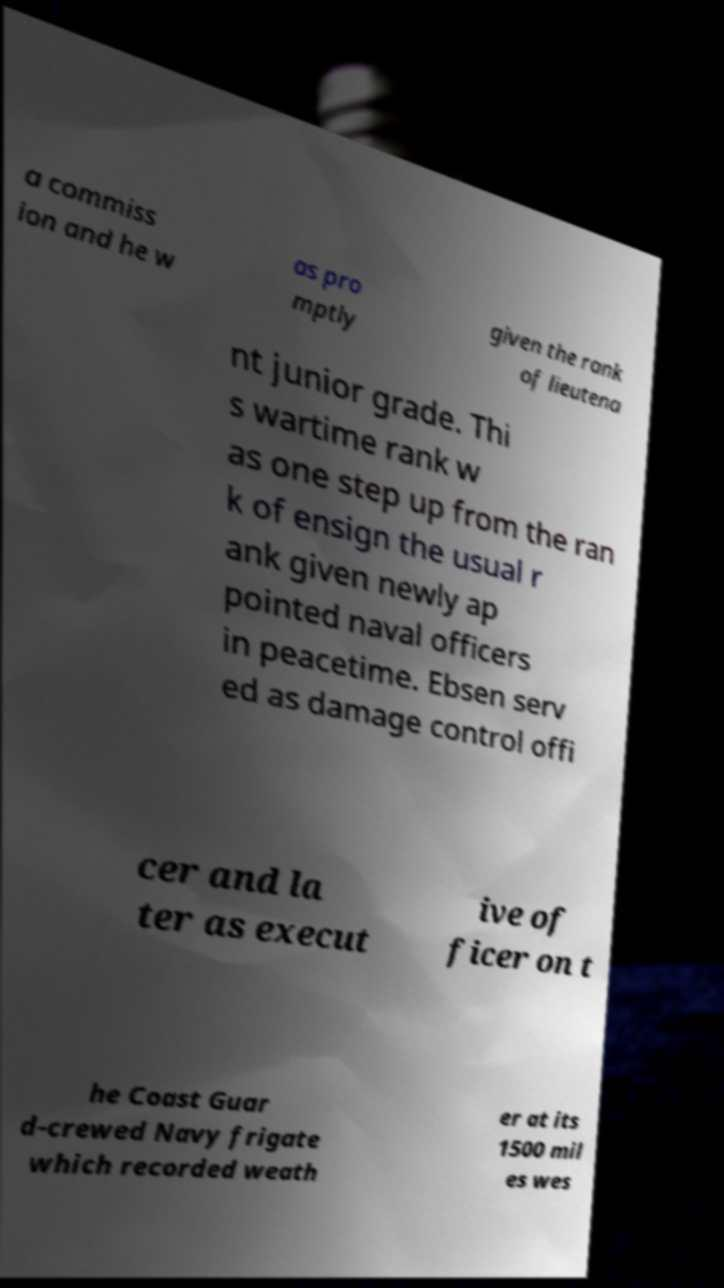Could you extract and type out the text from this image? a commiss ion and he w as pro mptly given the rank of lieutena nt junior grade. Thi s wartime rank w as one step up from the ran k of ensign the usual r ank given newly ap pointed naval officers in peacetime. Ebsen serv ed as damage control offi cer and la ter as execut ive of ficer on t he Coast Guar d-crewed Navy frigate which recorded weath er at its 1500 mil es wes 